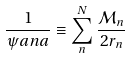Convert formula to latex. <formula><loc_0><loc_0><loc_500><loc_500>\frac { 1 } { \psi a n a } \equiv \sum _ { n } ^ { N } \frac { { \mathcal { M } } _ { n } } { 2 r _ { n } }</formula> 